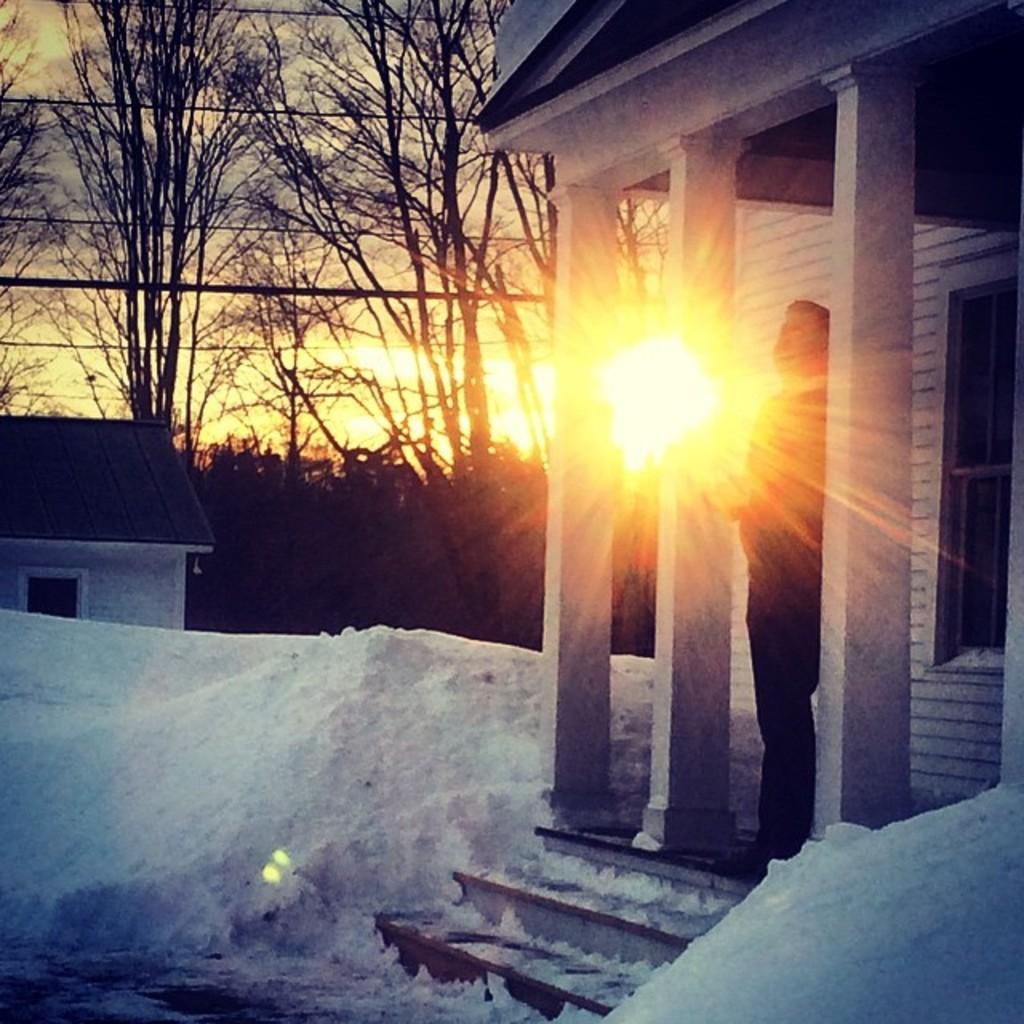Can you describe this image briefly? In this image there is a person standing on the porch of a building, in front of the person there are stairs and there is snow on the surface, in the background of the image there is a wooden house, trees, electrical cables and there are clouds and sun in the sky. 